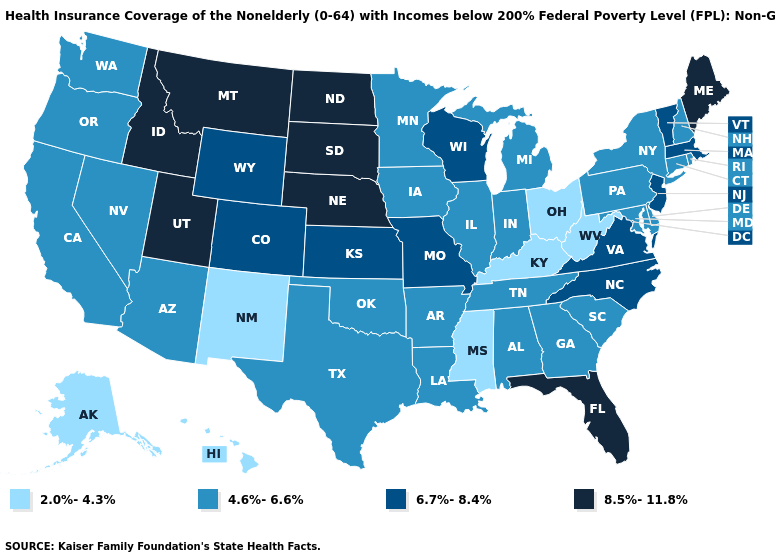Name the states that have a value in the range 4.6%-6.6%?
Answer briefly. Alabama, Arizona, Arkansas, California, Connecticut, Delaware, Georgia, Illinois, Indiana, Iowa, Louisiana, Maryland, Michigan, Minnesota, Nevada, New Hampshire, New York, Oklahoma, Oregon, Pennsylvania, Rhode Island, South Carolina, Tennessee, Texas, Washington. Among the states that border New Mexico , does Oklahoma have the lowest value?
Quick response, please. Yes. What is the value of Indiana?
Give a very brief answer. 4.6%-6.6%. What is the value of Connecticut?
Write a very short answer. 4.6%-6.6%. Does North Dakota have the same value as Tennessee?
Give a very brief answer. No. Name the states that have a value in the range 8.5%-11.8%?
Short answer required. Florida, Idaho, Maine, Montana, Nebraska, North Dakota, South Dakota, Utah. Does New Mexico have the lowest value in the USA?
Give a very brief answer. Yes. What is the value of Michigan?
Answer briefly. 4.6%-6.6%. What is the value of Hawaii?
Write a very short answer. 2.0%-4.3%. Name the states that have a value in the range 6.7%-8.4%?
Keep it brief. Colorado, Kansas, Massachusetts, Missouri, New Jersey, North Carolina, Vermont, Virginia, Wisconsin, Wyoming. Name the states that have a value in the range 8.5%-11.8%?
Keep it brief. Florida, Idaho, Maine, Montana, Nebraska, North Dakota, South Dakota, Utah. Does Florida have the highest value in the USA?
Keep it brief. Yes. Does Missouri have a higher value than New Jersey?
Give a very brief answer. No. What is the value of Kansas?
Answer briefly. 6.7%-8.4%. Name the states that have a value in the range 2.0%-4.3%?
Short answer required. Alaska, Hawaii, Kentucky, Mississippi, New Mexico, Ohio, West Virginia. 